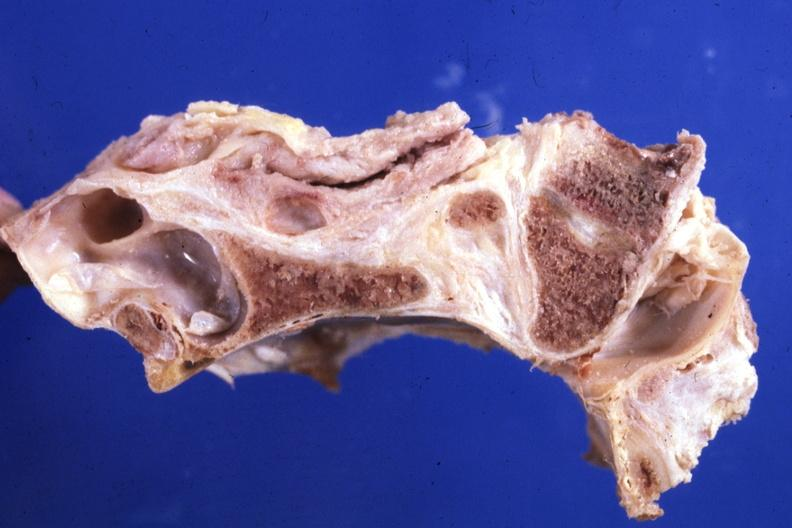does source show sagittal section of atlas vertebra and occipital bone foramen magnum stenosis case 31?
Answer the question using a single word or phrase. No 